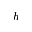<formula> <loc_0><loc_0><loc_500><loc_500>h</formula> 